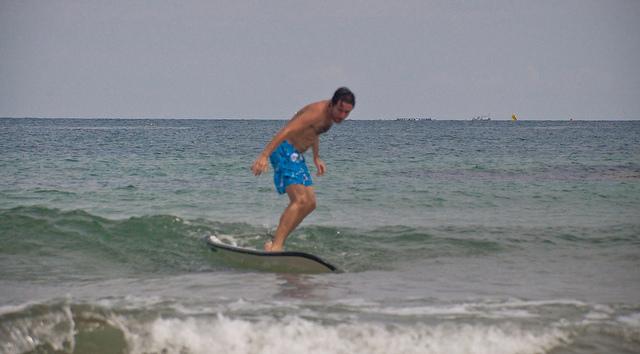Are these large waves?
Be succinct. No. What color are the man's shorts?
Keep it brief. Blue. What is the color of water?
Keep it brief. Green. How many people are in the scene?
Quick response, please. 1. Is the person scared to fall into the water?
Keep it brief. No. Is he wearing a wetsuit?
Quick response, please. No. Are there instructors in this image?
Quick response, please. No. What color are his swim trunks?
Concise answer only. Blue. 